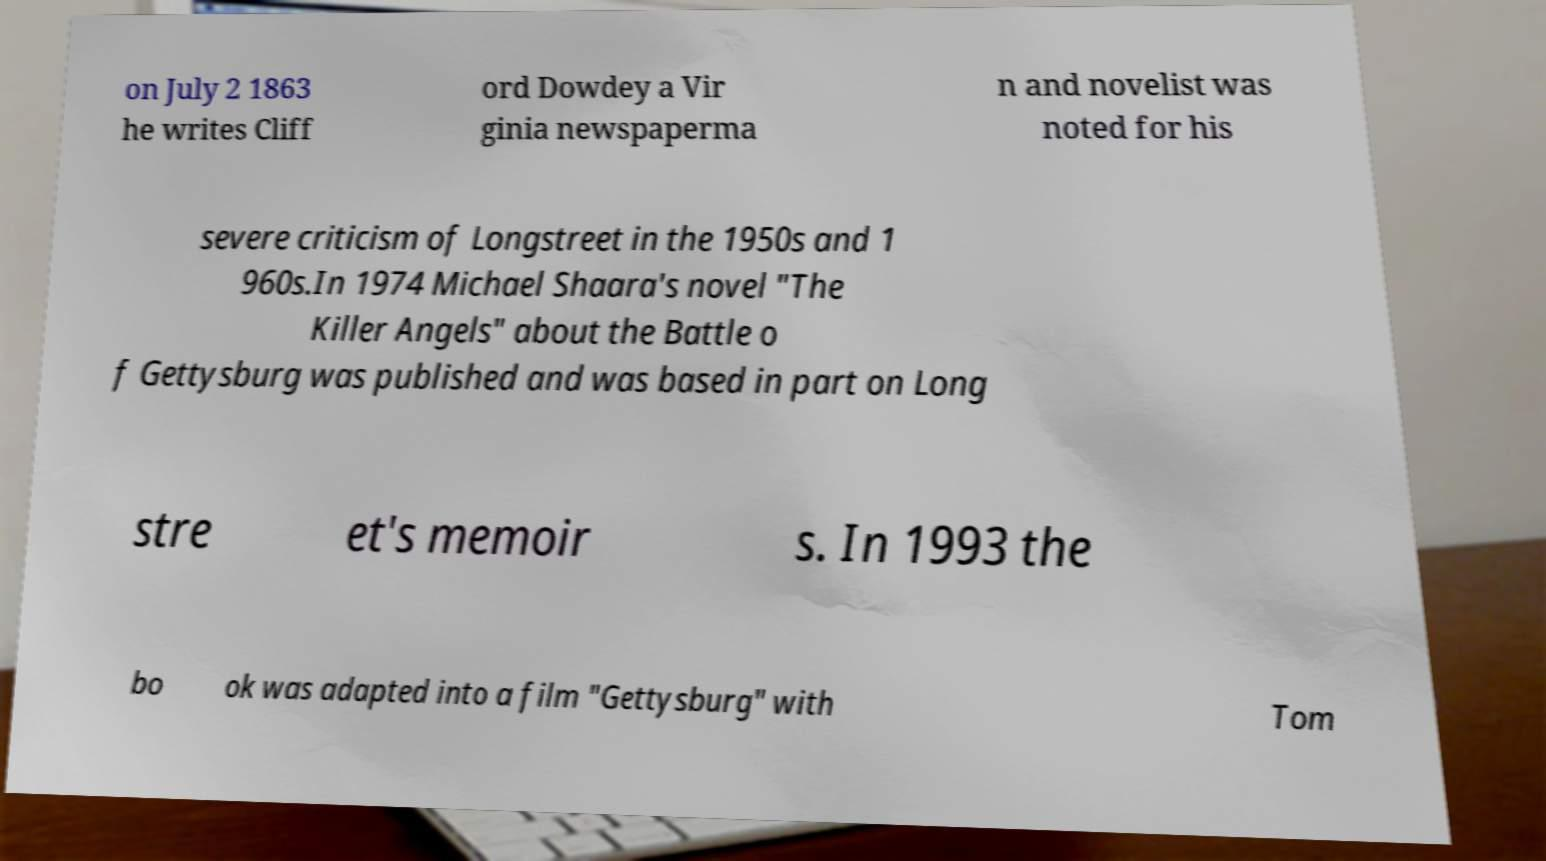For documentation purposes, I need the text within this image transcribed. Could you provide that? on July 2 1863 he writes Cliff ord Dowdey a Vir ginia newspaperma n and novelist was noted for his severe criticism of Longstreet in the 1950s and 1 960s.In 1974 Michael Shaara's novel "The Killer Angels" about the Battle o f Gettysburg was published and was based in part on Long stre et's memoir s. In 1993 the bo ok was adapted into a film "Gettysburg" with Tom 